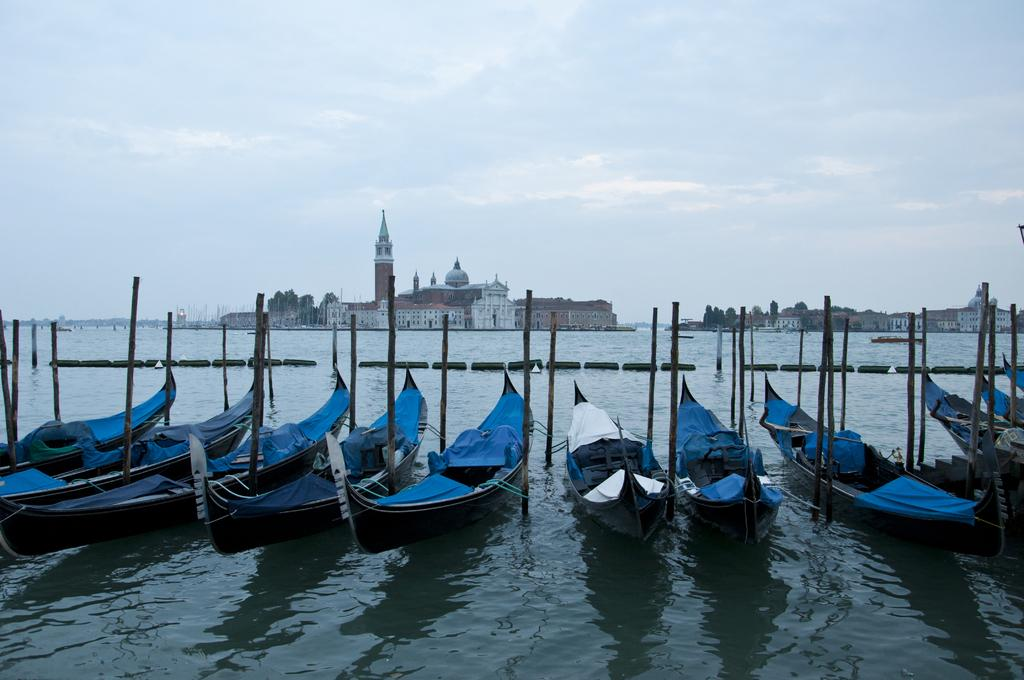What is the main subject of the image? The main subject of the image is a group of boats. Where are the boats located? The boats are in a water body. What other objects can be seen in the image? There are poles, barriers, buildings, and trees visible in the image. What is the condition of the sky in the image? The sky is visible in the image and appears cloudy. What type of haircut is the boat receiving in the image? There is no haircut present in the image, as the main subject is a group of boats in a water body. Can you tell me how many crates are visible in the image? There are no crates present in the image; the objects visible are boats, poles, barriers, buildings, and trees. 